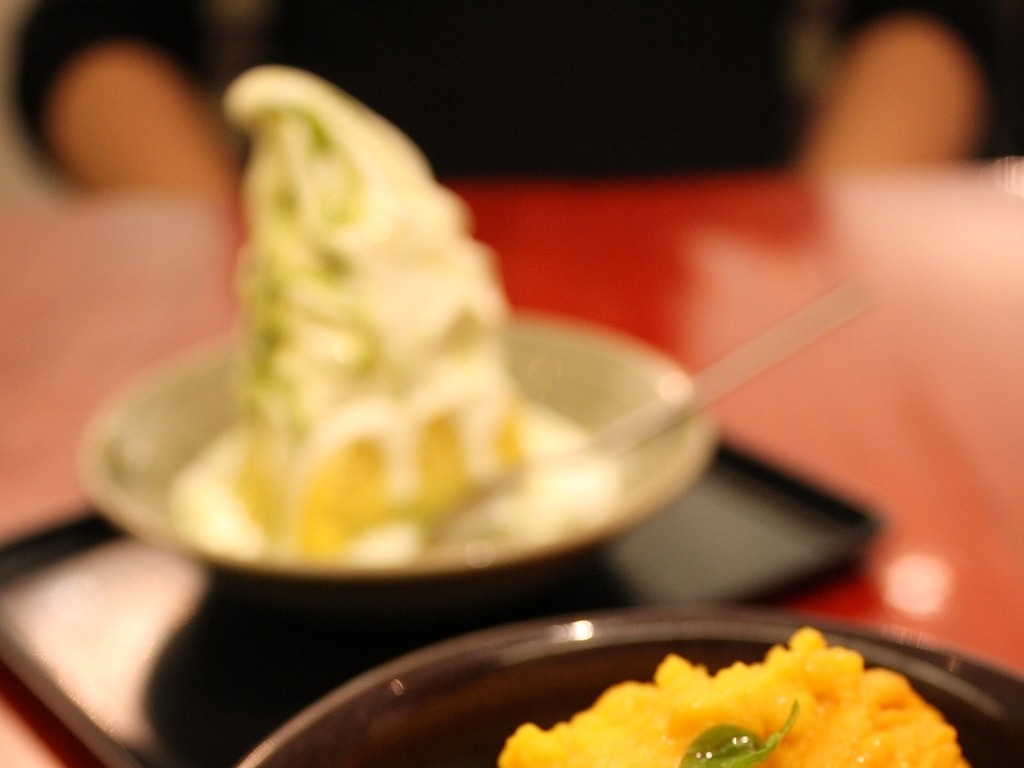How are the features in the image described? The image features an out-of-focus background with a person and depicts two distinct food items in the foreground: a creamy, swirl-shaped soft serve ice cream in a light pastel green hue resting in a clear bowl, and another dish with a vivid orange scoop of what appears to be a pumpkin or sweet potato mash with a green leaf garnish, both set against a dark, reflective tabletop. 